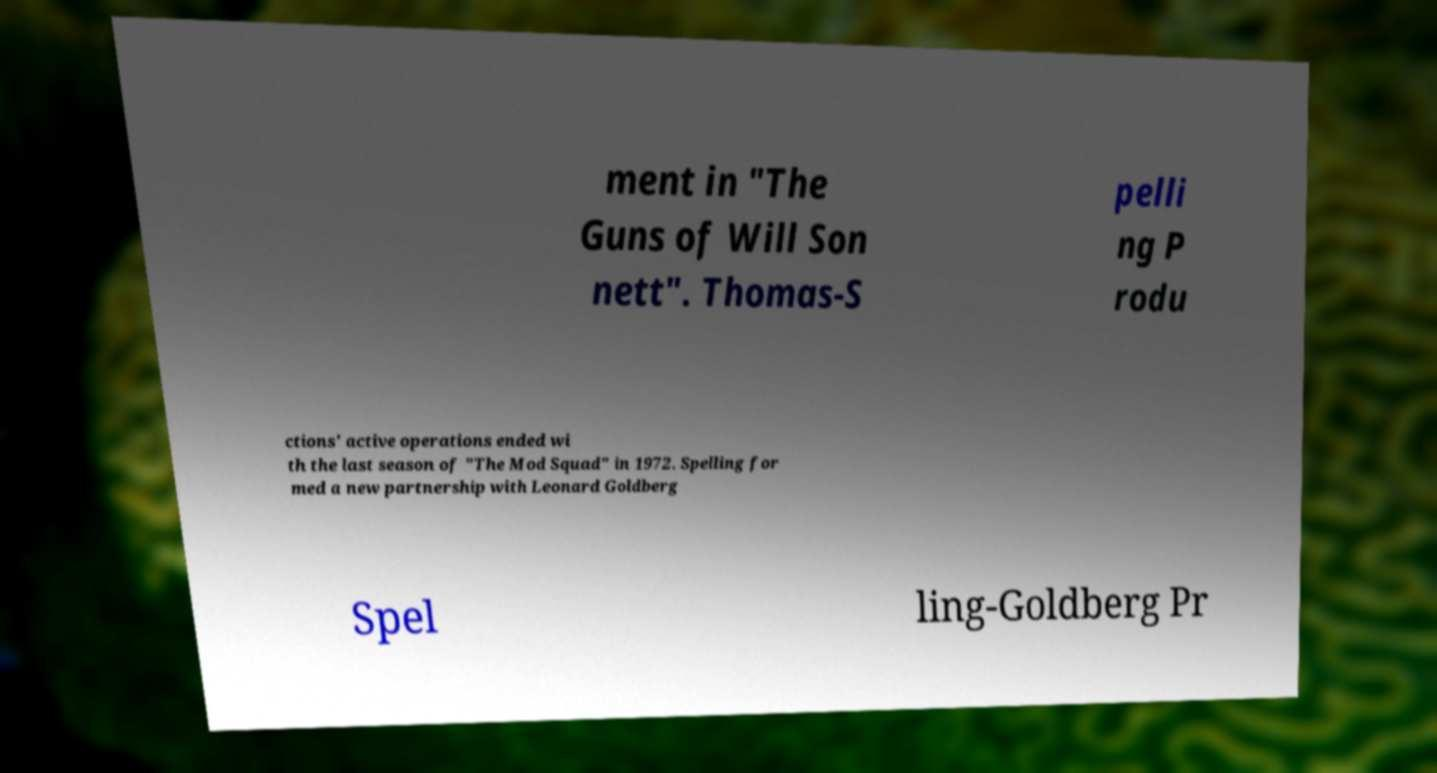Please identify and transcribe the text found in this image. ment in "The Guns of Will Son nett". Thomas-S pelli ng P rodu ctions' active operations ended wi th the last season of "The Mod Squad" in 1972. Spelling for med a new partnership with Leonard Goldberg Spel ling-Goldberg Pr 